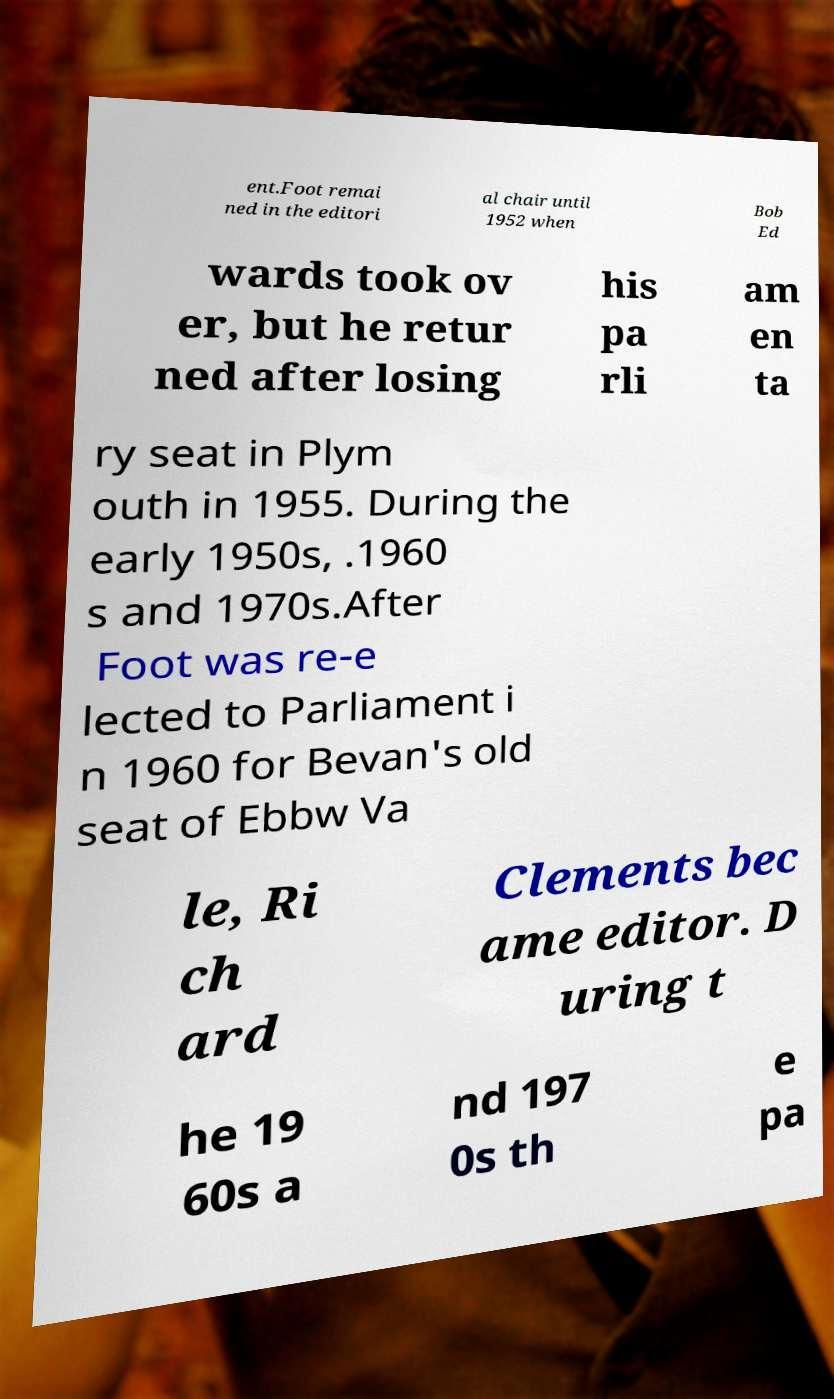I need the written content from this picture converted into text. Can you do that? ent.Foot remai ned in the editori al chair until 1952 when Bob Ed wards took ov er, but he retur ned after losing his pa rli am en ta ry seat in Plym outh in 1955. During the early 1950s, .1960 s and 1970s.After Foot was re-e lected to Parliament i n 1960 for Bevan's old seat of Ebbw Va le, Ri ch ard Clements bec ame editor. D uring t he 19 60s a nd 197 0s th e pa 